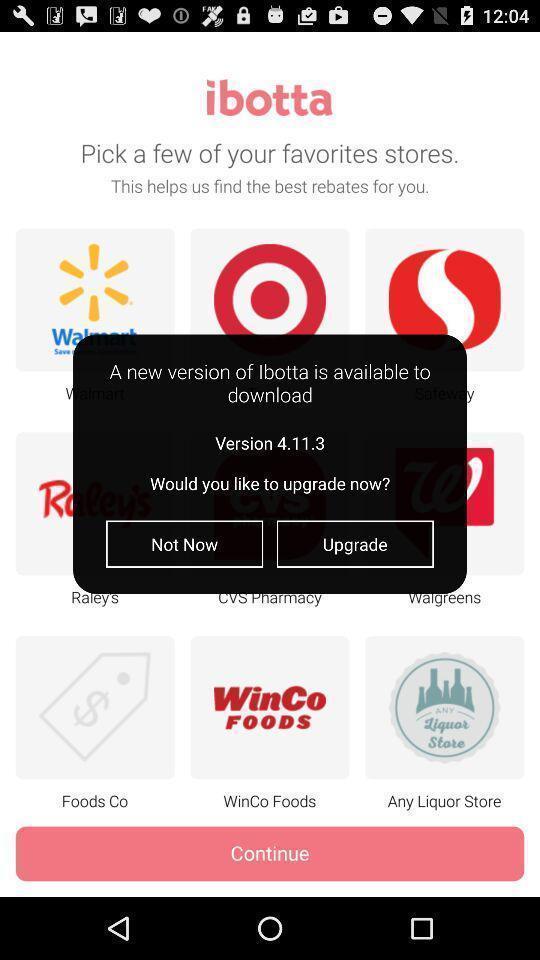Tell me about the visual elements in this screen capture. Popup to upgrade in the shopping app. 